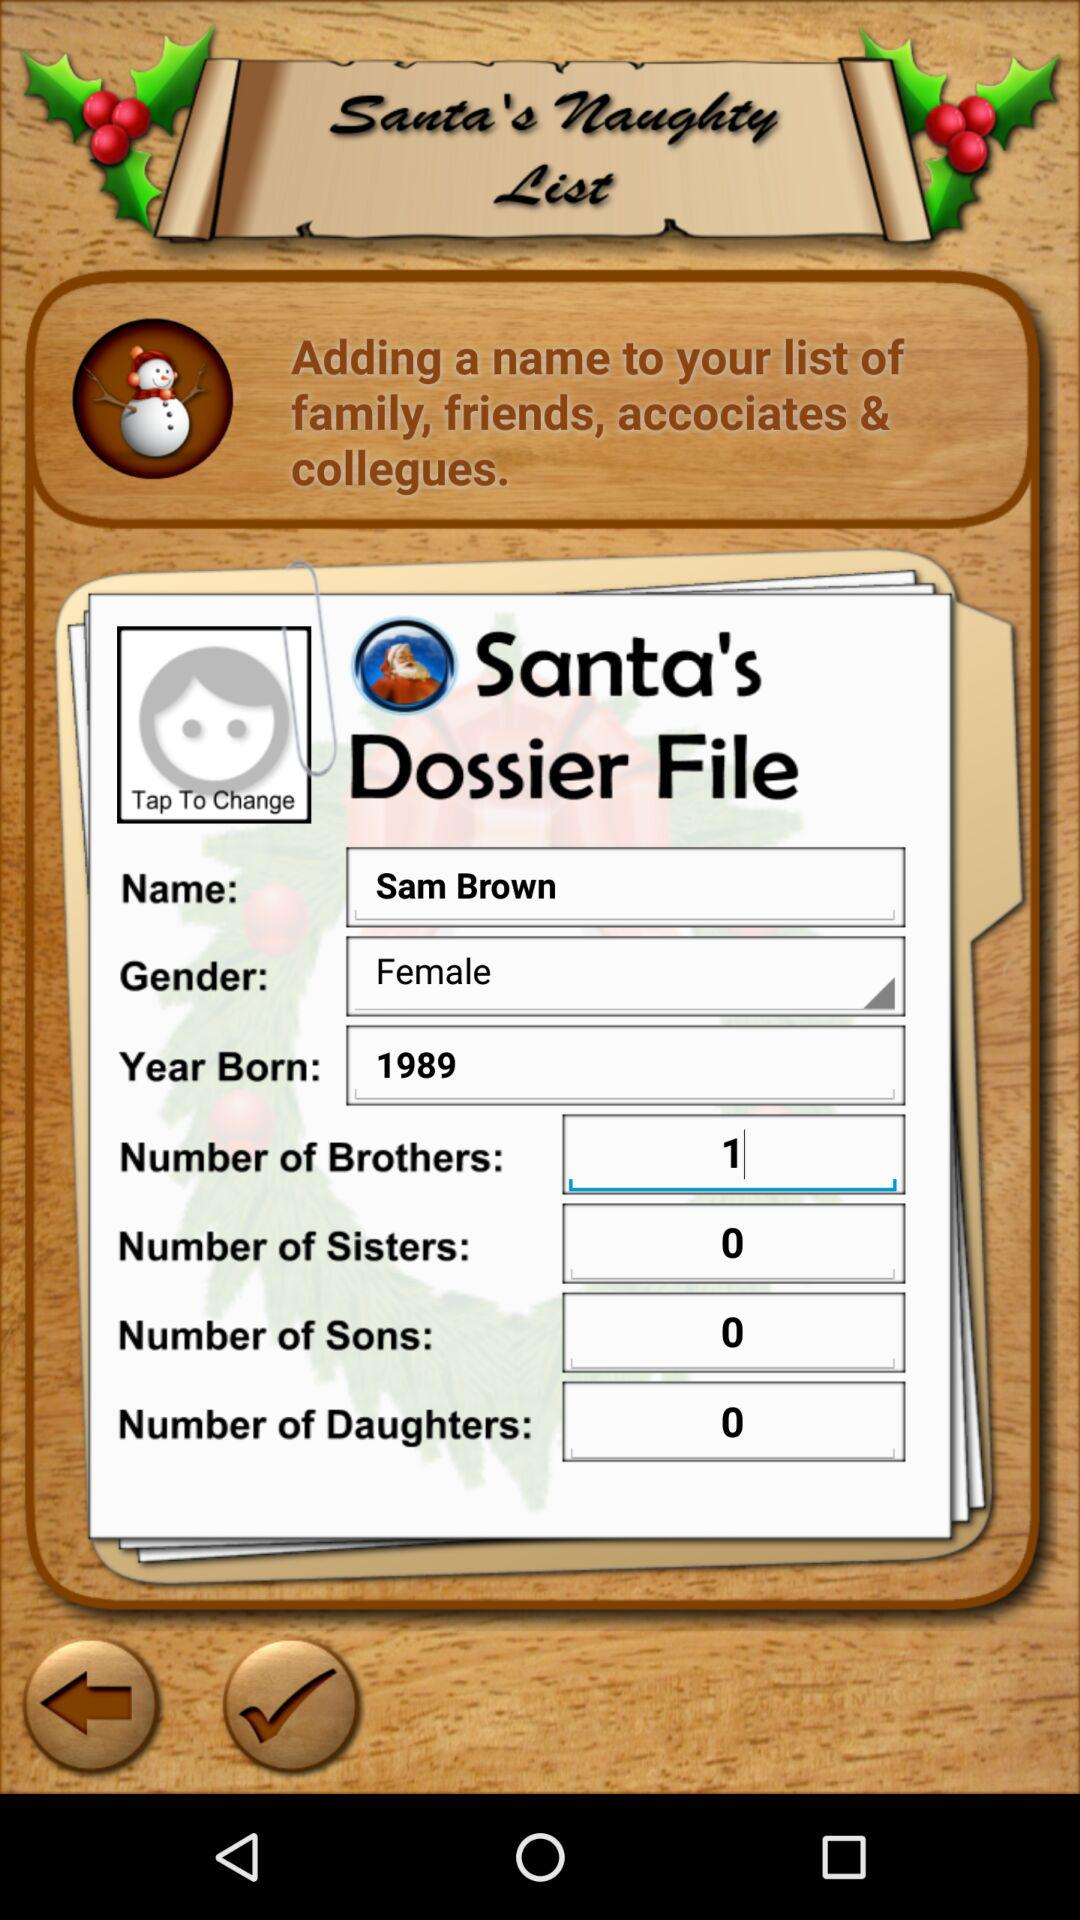What is the name of the user? The name of the user is Sam Brown. 